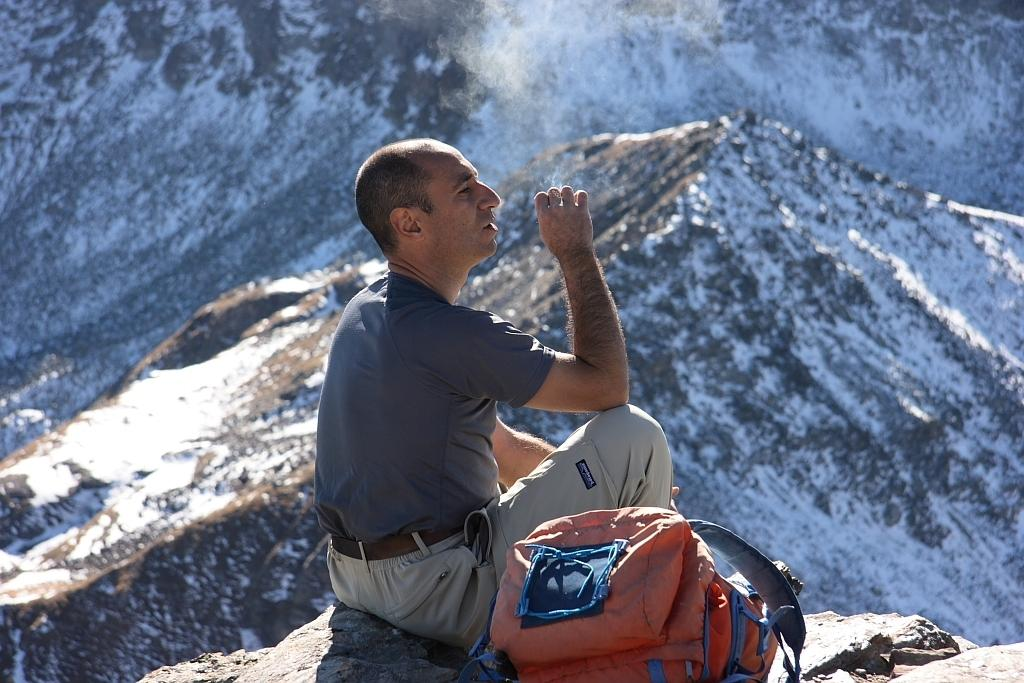What is the person in the image doing? The person is sitting on a rock in the image. What object is beside the person? The person has a bag beside them. What can be seen in the background of the image? Hills are visible in the background of the image. What is the condition of the hills? The hills are covered with snow. Where is the crate located in the image? There is no crate present in the image. What scientific experiments are being conducted in the image? There is no indication of any scientific experiments being conducted in the image. 